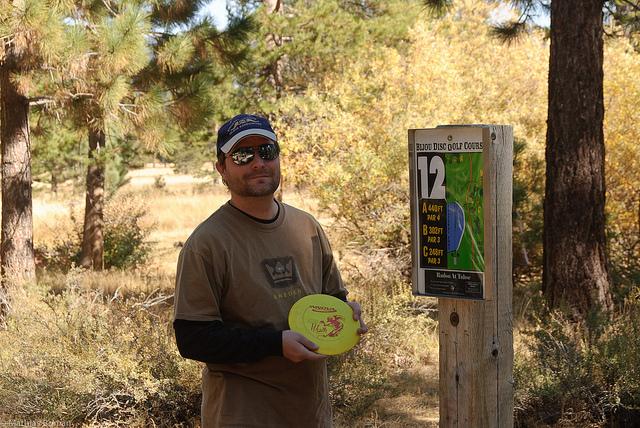What is the person holding on his hands?
Answer briefly. Frisbee. What does the sign say?
Short answer required. 12. Where are the sunglasses?
Give a very brief answer. On his face. What sport is this man engaged in?
Answer briefly. Frisbee. 